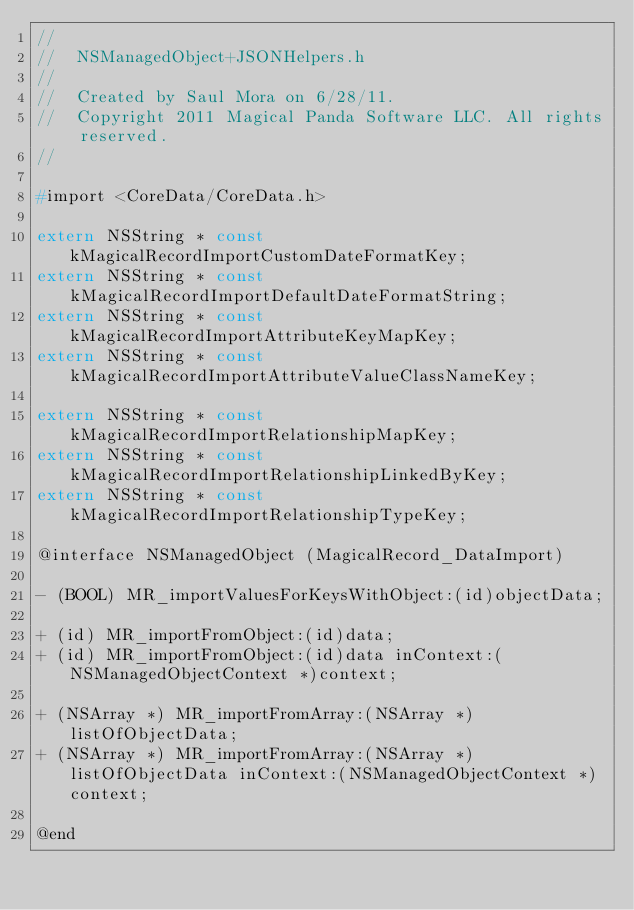<code> <loc_0><loc_0><loc_500><loc_500><_C_>//
//  NSManagedObject+JSONHelpers.h
//
//  Created by Saul Mora on 6/28/11.
//  Copyright 2011 Magical Panda Software LLC. All rights reserved.
//

#import <CoreData/CoreData.h>

extern NSString * const kMagicalRecordImportCustomDateFormatKey;
extern NSString * const kMagicalRecordImportDefaultDateFormatString;
extern NSString * const kMagicalRecordImportAttributeKeyMapKey;
extern NSString * const kMagicalRecordImportAttributeValueClassNameKey;

extern NSString * const kMagicalRecordImportRelationshipMapKey;
extern NSString * const kMagicalRecordImportRelationshipLinkedByKey;
extern NSString * const kMagicalRecordImportRelationshipTypeKey;

@interface NSManagedObject (MagicalRecord_DataImport)

- (BOOL) MR_importValuesForKeysWithObject:(id)objectData;

+ (id) MR_importFromObject:(id)data;
+ (id) MR_importFromObject:(id)data inContext:(NSManagedObjectContext *)context;

+ (NSArray *) MR_importFromArray:(NSArray *)listOfObjectData;
+ (NSArray *) MR_importFromArray:(NSArray *)listOfObjectData inContext:(NSManagedObjectContext *)context;

@end
</code> 